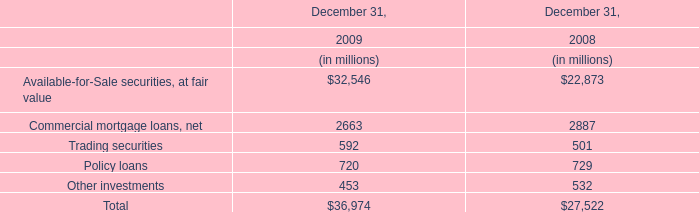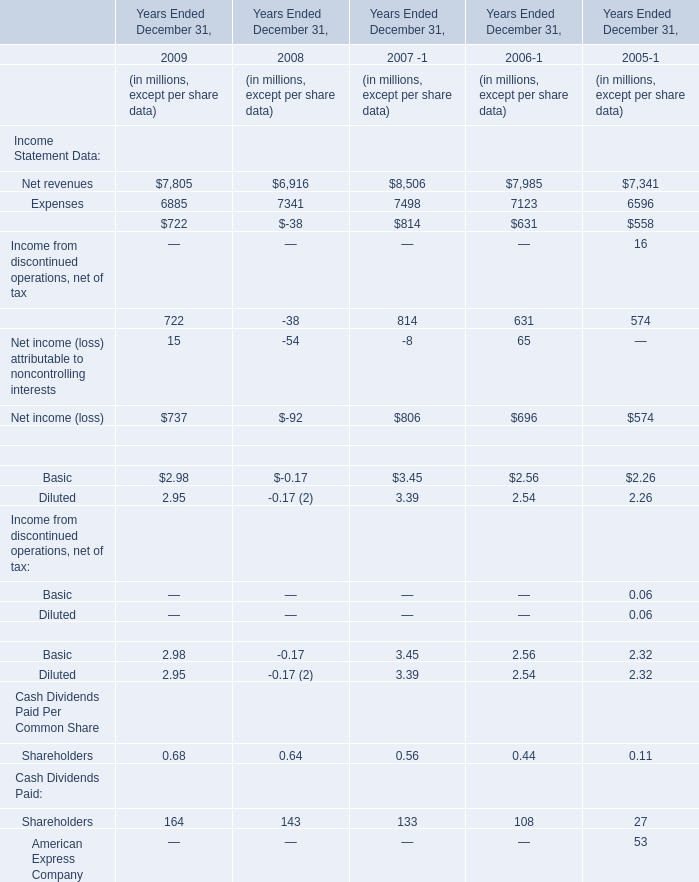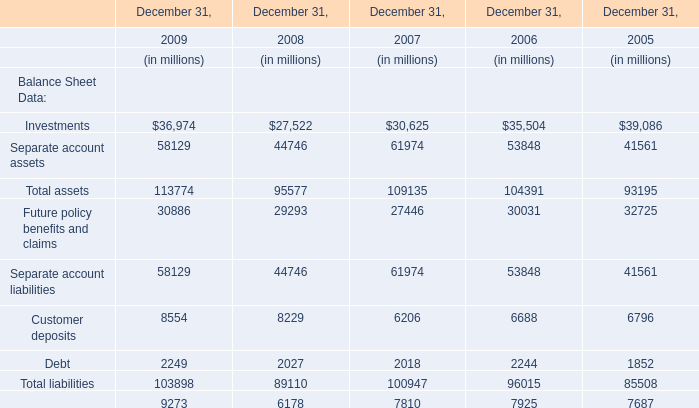what was the percentage change in cash paid for income taxes , net of refunds received between 2016 and 2017? 
Computations: ((40 - 15) / 15)
Answer: 1.66667. 